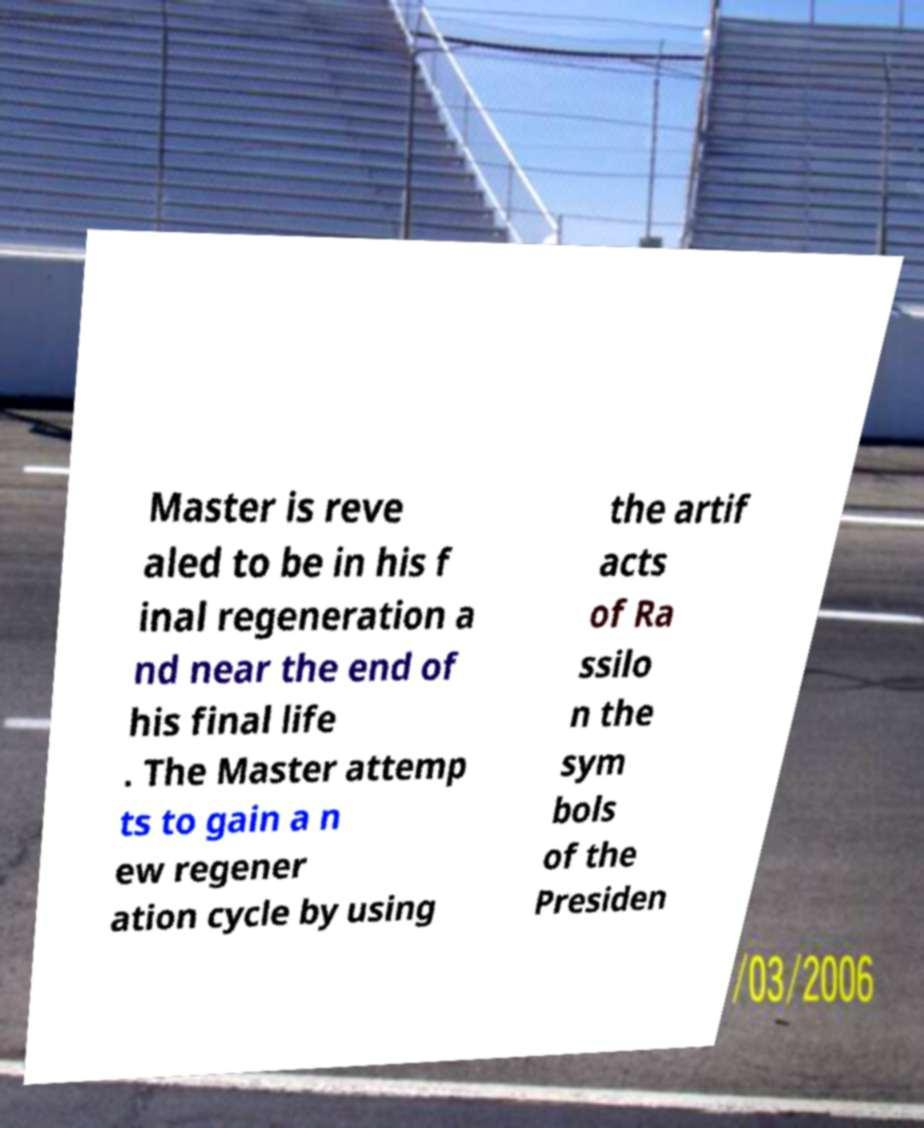There's text embedded in this image that I need extracted. Can you transcribe it verbatim? Master is reve aled to be in his f inal regeneration a nd near the end of his final life . The Master attemp ts to gain a n ew regener ation cycle by using the artif acts of Ra ssilo n the sym bols of the Presiden 